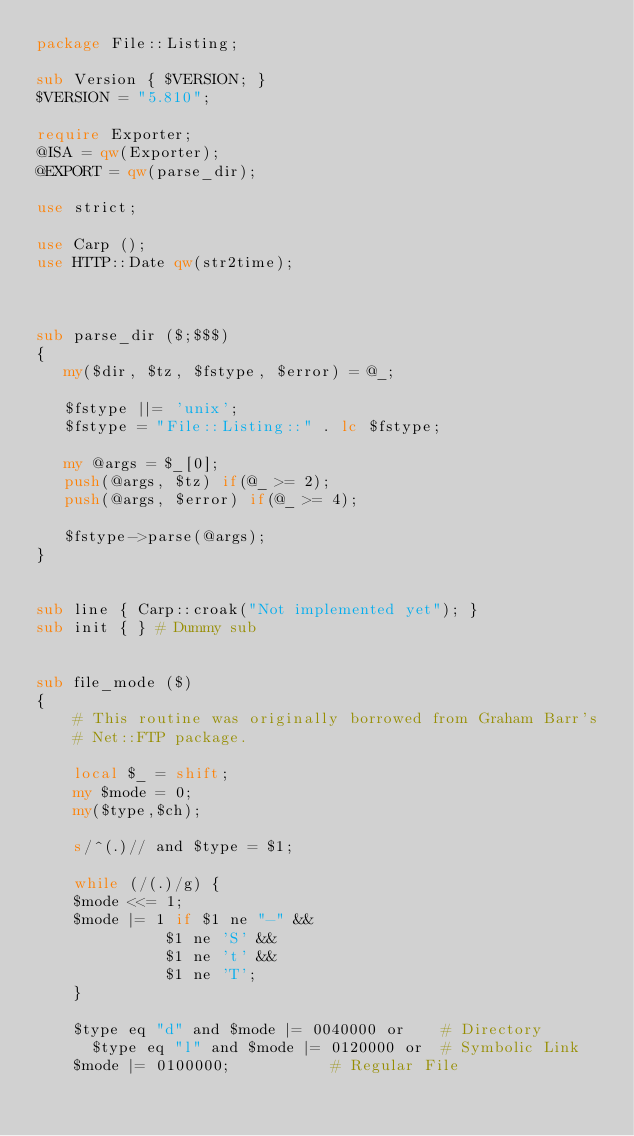<code> <loc_0><loc_0><loc_500><loc_500><_Perl_>package File::Listing;

sub Version { $VERSION; }
$VERSION = "5.810";

require Exporter;
@ISA = qw(Exporter);
@EXPORT = qw(parse_dir);

use strict;

use Carp ();
use HTTP::Date qw(str2time);



sub parse_dir ($;$$$)
{
   my($dir, $tz, $fstype, $error) = @_;

   $fstype ||= 'unix';
   $fstype = "File::Listing::" . lc $fstype;

   my @args = $_[0];
   push(@args, $tz) if(@_ >= 2);
   push(@args, $error) if(@_ >= 4);

   $fstype->parse(@args);
}


sub line { Carp::croak("Not implemented yet"); }
sub init { } # Dummy sub


sub file_mode ($)
{
    # This routine was originally borrowed from Graham Barr's
    # Net::FTP package.

    local $_ = shift;
    my $mode = 0;
    my($type,$ch);

    s/^(.)// and $type = $1;

    while (/(.)/g) {
	$mode <<= 1;
	$mode |= 1 if $1 ne "-" &&
		      $1 ne 'S' &&
		      $1 ne 't' &&
		      $1 ne 'T';
    }

    $type eq "d" and $mode |= 0040000 or	# Directory
      $type eq "l" and $mode |= 0120000 or	# Symbolic Link
	$mode |= 0100000;			# Regular File
</code> 